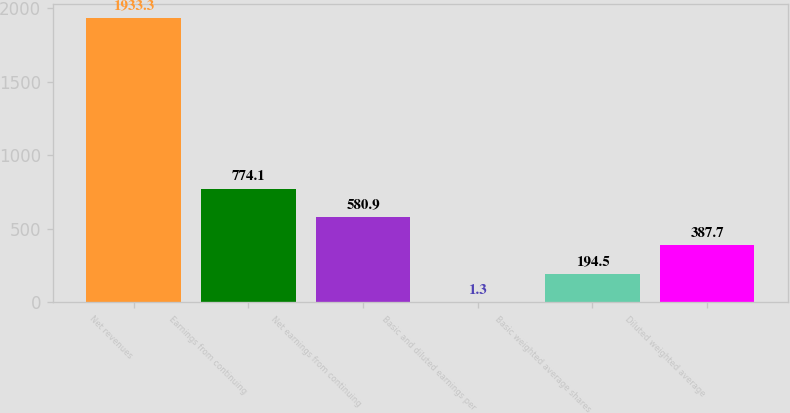Convert chart. <chart><loc_0><loc_0><loc_500><loc_500><bar_chart><fcel>Net revenues<fcel>Earnings from continuing<fcel>Net earnings from continuing<fcel>Basic and diluted earnings per<fcel>Basic weighted average shares<fcel>Diluted weighted average<nl><fcel>1933.3<fcel>774.1<fcel>580.9<fcel>1.3<fcel>194.5<fcel>387.7<nl></chart> 